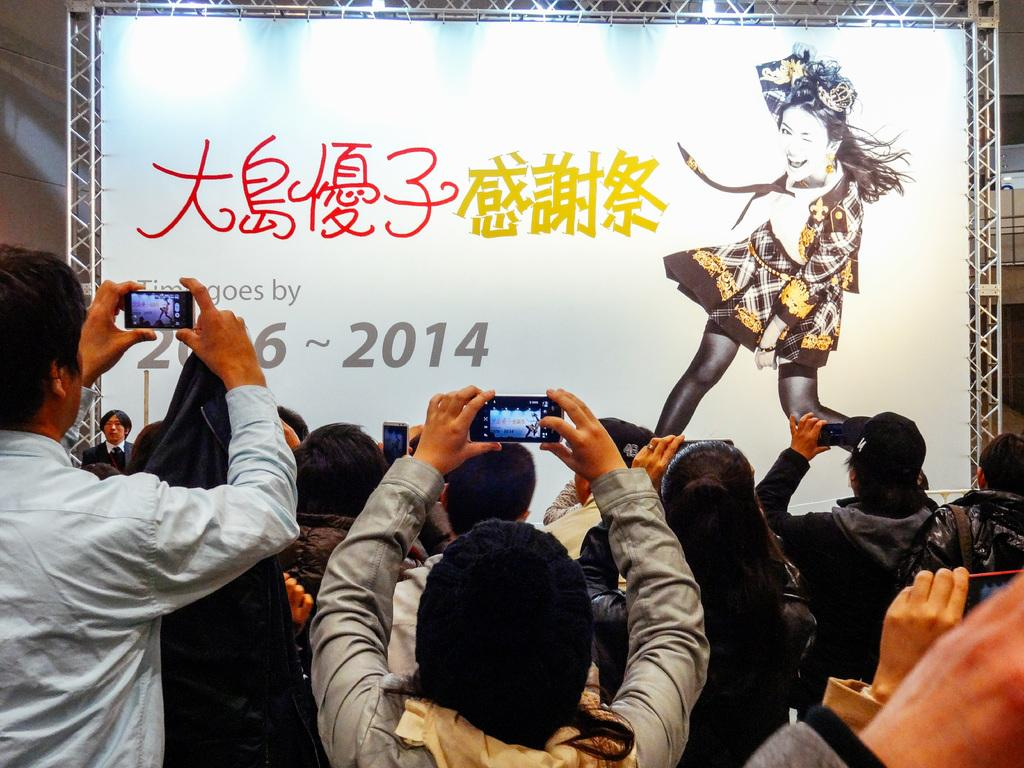What are the people in the image doing? The people in the image are holding cameras. What can be seen in the background of the image? There is a wall, a banner, and rods in the background of the image. What is depicted on the banner? The banner features a picture of a woman. What type of order is being placed by the cattle in the image? There are no cattle present in the image; it features a group of people holding cameras. Is there a cellar visible in the image? There is no mention of a cellar in the provided facts, and therefore it cannot be determined if one is present in the image. 